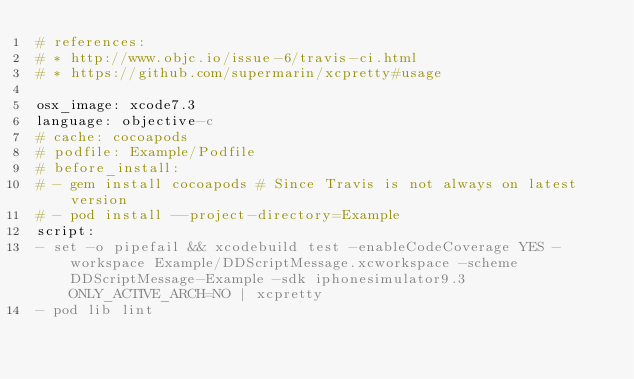Convert code to text. <code><loc_0><loc_0><loc_500><loc_500><_YAML_># references:
# * http://www.objc.io/issue-6/travis-ci.html
# * https://github.com/supermarin/xcpretty#usage

osx_image: xcode7.3
language: objective-c
# cache: cocoapods
# podfile: Example/Podfile
# before_install:
# - gem install cocoapods # Since Travis is not always on latest version
# - pod install --project-directory=Example
script:
- set -o pipefail && xcodebuild test -enableCodeCoverage YES -workspace Example/DDScriptMessage.xcworkspace -scheme DDScriptMessage-Example -sdk iphonesimulator9.3 ONLY_ACTIVE_ARCH=NO | xcpretty
- pod lib lint
</code> 